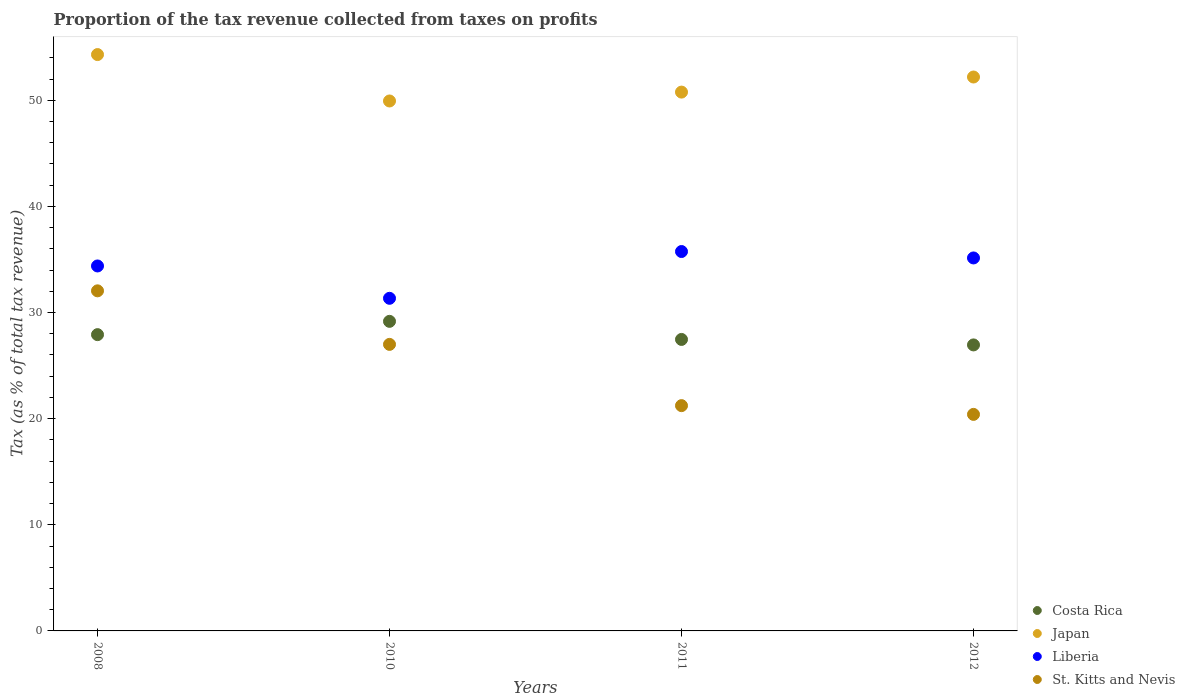What is the proportion of the tax revenue collected in St. Kitts and Nevis in 2012?
Offer a very short reply. 20.4. Across all years, what is the maximum proportion of the tax revenue collected in Japan?
Provide a short and direct response. 54.3. Across all years, what is the minimum proportion of the tax revenue collected in St. Kitts and Nevis?
Your answer should be compact. 20.4. In which year was the proportion of the tax revenue collected in Japan minimum?
Give a very brief answer. 2010. What is the total proportion of the tax revenue collected in Japan in the graph?
Offer a terse response. 207.19. What is the difference between the proportion of the tax revenue collected in Liberia in 2008 and that in 2012?
Keep it short and to the point. -0.76. What is the difference between the proportion of the tax revenue collected in St. Kitts and Nevis in 2011 and the proportion of the tax revenue collected in Liberia in 2008?
Offer a terse response. -13.16. What is the average proportion of the tax revenue collected in St. Kitts and Nevis per year?
Provide a succinct answer. 25.17. In the year 2010, what is the difference between the proportion of the tax revenue collected in Liberia and proportion of the tax revenue collected in Costa Rica?
Your answer should be very brief. 2.17. In how many years, is the proportion of the tax revenue collected in Liberia greater than 14 %?
Your response must be concise. 4. What is the ratio of the proportion of the tax revenue collected in Japan in 2008 to that in 2010?
Your answer should be very brief. 1.09. Is the proportion of the tax revenue collected in Costa Rica in 2008 less than that in 2012?
Ensure brevity in your answer.  No. What is the difference between the highest and the second highest proportion of the tax revenue collected in Liberia?
Provide a short and direct response. 0.6. What is the difference between the highest and the lowest proportion of the tax revenue collected in St. Kitts and Nevis?
Provide a short and direct response. 11.64. In how many years, is the proportion of the tax revenue collected in St. Kitts and Nevis greater than the average proportion of the tax revenue collected in St. Kitts and Nevis taken over all years?
Provide a short and direct response. 2. Is the sum of the proportion of the tax revenue collected in St. Kitts and Nevis in 2011 and 2012 greater than the maximum proportion of the tax revenue collected in Liberia across all years?
Keep it short and to the point. Yes. Is the proportion of the tax revenue collected in Japan strictly greater than the proportion of the tax revenue collected in St. Kitts and Nevis over the years?
Make the answer very short. Yes. Is the proportion of the tax revenue collected in Liberia strictly less than the proportion of the tax revenue collected in St. Kitts and Nevis over the years?
Ensure brevity in your answer.  No. How many dotlines are there?
Offer a terse response. 4. Are the values on the major ticks of Y-axis written in scientific E-notation?
Ensure brevity in your answer.  No. Does the graph contain any zero values?
Your answer should be very brief. No. Where does the legend appear in the graph?
Your response must be concise. Bottom right. What is the title of the graph?
Your answer should be very brief. Proportion of the tax revenue collected from taxes on profits. Does "Sudan" appear as one of the legend labels in the graph?
Make the answer very short. No. What is the label or title of the Y-axis?
Offer a terse response. Tax (as % of total tax revenue). What is the Tax (as % of total tax revenue) of Costa Rica in 2008?
Your response must be concise. 27.91. What is the Tax (as % of total tax revenue) of Japan in 2008?
Offer a terse response. 54.3. What is the Tax (as % of total tax revenue) in Liberia in 2008?
Offer a terse response. 34.38. What is the Tax (as % of total tax revenue) in St. Kitts and Nevis in 2008?
Make the answer very short. 32.04. What is the Tax (as % of total tax revenue) in Costa Rica in 2010?
Keep it short and to the point. 29.17. What is the Tax (as % of total tax revenue) in Japan in 2010?
Your response must be concise. 49.93. What is the Tax (as % of total tax revenue) in Liberia in 2010?
Provide a short and direct response. 31.34. What is the Tax (as % of total tax revenue) in St. Kitts and Nevis in 2010?
Provide a succinct answer. 27. What is the Tax (as % of total tax revenue) of Costa Rica in 2011?
Keep it short and to the point. 27.46. What is the Tax (as % of total tax revenue) in Japan in 2011?
Provide a short and direct response. 50.77. What is the Tax (as % of total tax revenue) of Liberia in 2011?
Ensure brevity in your answer.  35.74. What is the Tax (as % of total tax revenue) of St. Kitts and Nevis in 2011?
Ensure brevity in your answer.  21.23. What is the Tax (as % of total tax revenue) of Costa Rica in 2012?
Your answer should be very brief. 26.95. What is the Tax (as % of total tax revenue) of Japan in 2012?
Ensure brevity in your answer.  52.19. What is the Tax (as % of total tax revenue) in Liberia in 2012?
Provide a short and direct response. 35.14. What is the Tax (as % of total tax revenue) of St. Kitts and Nevis in 2012?
Provide a short and direct response. 20.4. Across all years, what is the maximum Tax (as % of total tax revenue) of Costa Rica?
Ensure brevity in your answer.  29.17. Across all years, what is the maximum Tax (as % of total tax revenue) of Japan?
Give a very brief answer. 54.3. Across all years, what is the maximum Tax (as % of total tax revenue) in Liberia?
Make the answer very short. 35.74. Across all years, what is the maximum Tax (as % of total tax revenue) of St. Kitts and Nevis?
Your answer should be compact. 32.04. Across all years, what is the minimum Tax (as % of total tax revenue) in Costa Rica?
Ensure brevity in your answer.  26.95. Across all years, what is the minimum Tax (as % of total tax revenue) of Japan?
Offer a very short reply. 49.93. Across all years, what is the minimum Tax (as % of total tax revenue) in Liberia?
Your response must be concise. 31.34. Across all years, what is the minimum Tax (as % of total tax revenue) of St. Kitts and Nevis?
Give a very brief answer. 20.4. What is the total Tax (as % of total tax revenue) of Costa Rica in the graph?
Provide a short and direct response. 111.49. What is the total Tax (as % of total tax revenue) in Japan in the graph?
Keep it short and to the point. 207.19. What is the total Tax (as % of total tax revenue) of Liberia in the graph?
Provide a short and direct response. 136.61. What is the total Tax (as % of total tax revenue) in St. Kitts and Nevis in the graph?
Provide a short and direct response. 100.67. What is the difference between the Tax (as % of total tax revenue) in Costa Rica in 2008 and that in 2010?
Your answer should be compact. -1.25. What is the difference between the Tax (as % of total tax revenue) of Japan in 2008 and that in 2010?
Ensure brevity in your answer.  4.37. What is the difference between the Tax (as % of total tax revenue) of Liberia in 2008 and that in 2010?
Provide a short and direct response. 3.05. What is the difference between the Tax (as % of total tax revenue) of St. Kitts and Nevis in 2008 and that in 2010?
Offer a terse response. 5.04. What is the difference between the Tax (as % of total tax revenue) of Costa Rica in 2008 and that in 2011?
Your answer should be compact. 0.45. What is the difference between the Tax (as % of total tax revenue) in Japan in 2008 and that in 2011?
Your answer should be very brief. 3.54. What is the difference between the Tax (as % of total tax revenue) of Liberia in 2008 and that in 2011?
Your answer should be very brief. -1.36. What is the difference between the Tax (as % of total tax revenue) of St. Kitts and Nevis in 2008 and that in 2011?
Offer a terse response. 10.82. What is the difference between the Tax (as % of total tax revenue) of Costa Rica in 2008 and that in 2012?
Provide a succinct answer. 0.97. What is the difference between the Tax (as % of total tax revenue) of Japan in 2008 and that in 2012?
Provide a succinct answer. 2.12. What is the difference between the Tax (as % of total tax revenue) in Liberia in 2008 and that in 2012?
Offer a terse response. -0.76. What is the difference between the Tax (as % of total tax revenue) of St. Kitts and Nevis in 2008 and that in 2012?
Ensure brevity in your answer.  11.64. What is the difference between the Tax (as % of total tax revenue) in Costa Rica in 2010 and that in 2011?
Give a very brief answer. 1.7. What is the difference between the Tax (as % of total tax revenue) of Japan in 2010 and that in 2011?
Your response must be concise. -0.84. What is the difference between the Tax (as % of total tax revenue) in Liberia in 2010 and that in 2011?
Provide a succinct answer. -4.41. What is the difference between the Tax (as % of total tax revenue) of St. Kitts and Nevis in 2010 and that in 2011?
Provide a short and direct response. 5.77. What is the difference between the Tax (as % of total tax revenue) in Costa Rica in 2010 and that in 2012?
Ensure brevity in your answer.  2.22. What is the difference between the Tax (as % of total tax revenue) of Japan in 2010 and that in 2012?
Give a very brief answer. -2.26. What is the difference between the Tax (as % of total tax revenue) of Liberia in 2010 and that in 2012?
Offer a very short reply. -3.8. What is the difference between the Tax (as % of total tax revenue) in St. Kitts and Nevis in 2010 and that in 2012?
Give a very brief answer. 6.6. What is the difference between the Tax (as % of total tax revenue) in Costa Rica in 2011 and that in 2012?
Offer a very short reply. 0.52. What is the difference between the Tax (as % of total tax revenue) in Japan in 2011 and that in 2012?
Provide a succinct answer. -1.42. What is the difference between the Tax (as % of total tax revenue) of Liberia in 2011 and that in 2012?
Your response must be concise. 0.6. What is the difference between the Tax (as % of total tax revenue) in St. Kitts and Nevis in 2011 and that in 2012?
Offer a very short reply. 0.82. What is the difference between the Tax (as % of total tax revenue) in Costa Rica in 2008 and the Tax (as % of total tax revenue) in Japan in 2010?
Provide a short and direct response. -22.02. What is the difference between the Tax (as % of total tax revenue) in Costa Rica in 2008 and the Tax (as % of total tax revenue) in Liberia in 2010?
Provide a succinct answer. -3.42. What is the difference between the Tax (as % of total tax revenue) of Costa Rica in 2008 and the Tax (as % of total tax revenue) of St. Kitts and Nevis in 2010?
Give a very brief answer. 0.92. What is the difference between the Tax (as % of total tax revenue) in Japan in 2008 and the Tax (as % of total tax revenue) in Liberia in 2010?
Make the answer very short. 22.96. What is the difference between the Tax (as % of total tax revenue) in Japan in 2008 and the Tax (as % of total tax revenue) in St. Kitts and Nevis in 2010?
Your answer should be very brief. 27.31. What is the difference between the Tax (as % of total tax revenue) in Liberia in 2008 and the Tax (as % of total tax revenue) in St. Kitts and Nevis in 2010?
Ensure brevity in your answer.  7.39. What is the difference between the Tax (as % of total tax revenue) of Costa Rica in 2008 and the Tax (as % of total tax revenue) of Japan in 2011?
Your response must be concise. -22.85. What is the difference between the Tax (as % of total tax revenue) in Costa Rica in 2008 and the Tax (as % of total tax revenue) in Liberia in 2011?
Make the answer very short. -7.83. What is the difference between the Tax (as % of total tax revenue) in Costa Rica in 2008 and the Tax (as % of total tax revenue) in St. Kitts and Nevis in 2011?
Offer a very short reply. 6.69. What is the difference between the Tax (as % of total tax revenue) of Japan in 2008 and the Tax (as % of total tax revenue) of Liberia in 2011?
Offer a terse response. 18.56. What is the difference between the Tax (as % of total tax revenue) in Japan in 2008 and the Tax (as % of total tax revenue) in St. Kitts and Nevis in 2011?
Provide a succinct answer. 33.08. What is the difference between the Tax (as % of total tax revenue) of Liberia in 2008 and the Tax (as % of total tax revenue) of St. Kitts and Nevis in 2011?
Your answer should be very brief. 13.16. What is the difference between the Tax (as % of total tax revenue) of Costa Rica in 2008 and the Tax (as % of total tax revenue) of Japan in 2012?
Give a very brief answer. -24.27. What is the difference between the Tax (as % of total tax revenue) in Costa Rica in 2008 and the Tax (as % of total tax revenue) in Liberia in 2012?
Provide a short and direct response. -7.23. What is the difference between the Tax (as % of total tax revenue) of Costa Rica in 2008 and the Tax (as % of total tax revenue) of St. Kitts and Nevis in 2012?
Your response must be concise. 7.51. What is the difference between the Tax (as % of total tax revenue) in Japan in 2008 and the Tax (as % of total tax revenue) in Liberia in 2012?
Ensure brevity in your answer.  19.16. What is the difference between the Tax (as % of total tax revenue) in Japan in 2008 and the Tax (as % of total tax revenue) in St. Kitts and Nevis in 2012?
Provide a succinct answer. 33.9. What is the difference between the Tax (as % of total tax revenue) of Liberia in 2008 and the Tax (as % of total tax revenue) of St. Kitts and Nevis in 2012?
Give a very brief answer. 13.98. What is the difference between the Tax (as % of total tax revenue) in Costa Rica in 2010 and the Tax (as % of total tax revenue) in Japan in 2011?
Offer a terse response. -21.6. What is the difference between the Tax (as % of total tax revenue) in Costa Rica in 2010 and the Tax (as % of total tax revenue) in Liberia in 2011?
Give a very brief answer. -6.58. What is the difference between the Tax (as % of total tax revenue) in Costa Rica in 2010 and the Tax (as % of total tax revenue) in St. Kitts and Nevis in 2011?
Keep it short and to the point. 7.94. What is the difference between the Tax (as % of total tax revenue) of Japan in 2010 and the Tax (as % of total tax revenue) of Liberia in 2011?
Ensure brevity in your answer.  14.18. What is the difference between the Tax (as % of total tax revenue) of Japan in 2010 and the Tax (as % of total tax revenue) of St. Kitts and Nevis in 2011?
Offer a very short reply. 28.7. What is the difference between the Tax (as % of total tax revenue) of Liberia in 2010 and the Tax (as % of total tax revenue) of St. Kitts and Nevis in 2011?
Ensure brevity in your answer.  10.11. What is the difference between the Tax (as % of total tax revenue) in Costa Rica in 2010 and the Tax (as % of total tax revenue) in Japan in 2012?
Provide a short and direct response. -23.02. What is the difference between the Tax (as % of total tax revenue) of Costa Rica in 2010 and the Tax (as % of total tax revenue) of Liberia in 2012?
Your answer should be compact. -5.97. What is the difference between the Tax (as % of total tax revenue) of Costa Rica in 2010 and the Tax (as % of total tax revenue) of St. Kitts and Nevis in 2012?
Keep it short and to the point. 8.77. What is the difference between the Tax (as % of total tax revenue) of Japan in 2010 and the Tax (as % of total tax revenue) of Liberia in 2012?
Provide a succinct answer. 14.79. What is the difference between the Tax (as % of total tax revenue) of Japan in 2010 and the Tax (as % of total tax revenue) of St. Kitts and Nevis in 2012?
Make the answer very short. 29.53. What is the difference between the Tax (as % of total tax revenue) of Liberia in 2010 and the Tax (as % of total tax revenue) of St. Kitts and Nevis in 2012?
Ensure brevity in your answer.  10.94. What is the difference between the Tax (as % of total tax revenue) in Costa Rica in 2011 and the Tax (as % of total tax revenue) in Japan in 2012?
Your answer should be compact. -24.72. What is the difference between the Tax (as % of total tax revenue) in Costa Rica in 2011 and the Tax (as % of total tax revenue) in Liberia in 2012?
Ensure brevity in your answer.  -7.68. What is the difference between the Tax (as % of total tax revenue) in Costa Rica in 2011 and the Tax (as % of total tax revenue) in St. Kitts and Nevis in 2012?
Provide a short and direct response. 7.06. What is the difference between the Tax (as % of total tax revenue) of Japan in 2011 and the Tax (as % of total tax revenue) of Liberia in 2012?
Give a very brief answer. 15.63. What is the difference between the Tax (as % of total tax revenue) of Japan in 2011 and the Tax (as % of total tax revenue) of St. Kitts and Nevis in 2012?
Make the answer very short. 30.37. What is the difference between the Tax (as % of total tax revenue) in Liberia in 2011 and the Tax (as % of total tax revenue) in St. Kitts and Nevis in 2012?
Ensure brevity in your answer.  15.34. What is the average Tax (as % of total tax revenue) of Costa Rica per year?
Provide a short and direct response. 27.87. What is the average Tax (as % of total tax revenue) of Japan per year?
Your response must be concise. 51.8. What is the average Tax (as % of total tax revenue) in Liberia per year?
Your answer should be very brief. 34.15. What is the average Tax (as % of total tax revenue) of St. Kitts and Nevis per year?
Your answer should be very brief. 25.17. In the year 2008, what is the difference between the Tax (as % of total tax revenue) in Costa Rica and Tax (as % of total tax revenue) in Japan?
Provide a short and direct response. -26.39. In the year 2008, what is the difference between the Tax (as % of total tax revenue) in Costa Rica and Tax (as % of total tax revenue) in Liberia?
Make the answer very short. -6.47. In the year 2008, what is the difference between the Tax (as % of total tax revenue) in Costa Rica and Tax (as % of total tax revenue) in St. Kitts and Nevis?
Your response must be concise. -4.13. In the year 2008, what is the difference between the Tax (as % of total tax revenue) of Japan and Tax (as % of total tax revenue) of Liberia?
Give a very brief answer. 19.92. In the year 2008, what is the difference between the Tax (as % of total tax revenue) in Japan and Tax (as % of total tax revenue) in St. Kitts and Nevis?
Your answer should be very brief. 22.26. In the year 2008, what is the difference between the Tax (as % of total tax revenue) in Liberia and Tax (as % of total tax revenue) in St. Kitts and Nevis?
Offer a terse response. 2.34. In the year 2010, what is the difference between the Tax (as % of total tax revenue) in Costa Rica and Tax (as % of total tax revenue) in Japan?
Provide a short and direct response. -20.76. In the year 2010, what is the difference between the Tax (as % of total tax revenue) of Costa Rica and Tax (as % of total tax revenue) of Liberia?
Ensure brevity in your answer.  -2.17. In the year 2010, what is the difference between the Tax (as % of total tax revenue) of Costa Rica and Tax (as % of total tax revenue) of St. Kitts and Nevis?
Offer a terse response. 2.17. In the year 2010, what is the difference between the Tax (as % of total tax revenue) in Japan and Tax (as % of total tax revenue) in Liberia?
Keep it short and to the point. 18.59. In the year 2010, what is the difference between the Tax (as % of total tax revenue) in Japan and Tax (as % of total tax revenue) in St. Kitts and Nevis?
Ensure brevity in your answer.  22.93. In the year 2010, what is the difference between the Tax (as % of total tax revenue) of Liberia and Tax (as % of total tax revenue) of St. Kitts and Nevis?
Offer a very short reply. 4.34. In the year 2011, what is the difference between the Tax (as % of total tax revenue) in Costa Rica and Tax (as % of total tax revenue) in Japan?
Provide a succinct answer. -23.3. In the year 2011, what is the difference between the Tax (as % of total tax revenue) of Costa Rica and Tax (as % of total tax revenue) of Liberia?
Ensure brevity in your answer.  -8.28. In the year 2011, what is the difference between the Tax (as % of total tax revenue) of Costa Rica and Tax (as % of total tax revenue) of St. Kitts and Nevis?
Keep it short and to the point. 6.24. In the year 2011, what is the difference between the Tax (as % of total tax revenue) in Japan and Tax (as % of total tax revenue) in Liberia?
Offer a very short reply. 15.02. In the year 2011, what is the difference between the Tax (as % of total tax revenue) of Japan and Tax (as % of total tax revenue) of St. Kitts and Nevis?
Offer a terse response. 29.54. In the year 2011, what is the difference between the Tax (as % of total tax revenue) in Liberia and Tax (as % of total tax revenue) in St. Kitts and Nevis?
Offer a very short reply. 14.52. In the year 2012, what is the difference between the Tax (as % of total tax revenue) in Costa Rica and Tax (as % of total tax revenue) in Japan?
Give a very brief answer. -25.24. In the year 2012, what is the difference between the Tax (as % of total tax revenue) of Costa Rica and Tax (as % of total tax revenue) of Liberia?
Your answer should be compact. -8.19. In the year 2012, what is the difference between the Tax (as % of total tax revenue) in Costa Rica and Tax (as % of total tax revenue) in St. Kitts and Nevis?
Offer a very short reply. 6.55. In the year 2012, what is the difference between the Tax (as % of total tax revenue) of Japan and Tax (as % of total tax revenue) of Liberia?
Provide a succinct answer. 17.05. In the year 2012, what is the difference between the Tax (as % of total tax revenue) of Japan and Tax (as % of total tax revenue) of St. Kitts and Nevis?
Provide a succinct answer. 31.79. In the year 2012, what is the difference between the Tax (as % of total tax revenue) in Liberia and Tax (as % of total tax revenue) in St. Kitts and Nevis?
Keep it short and to the point. 14.74. What is the ratio of the Tax (as % of total tax revenue) in Costa Rica in 2008 to that in 2010?
Your response must be concise. 0.96. What is the ratio of the Tax (as % of total tax revenue) of Japan in 2008 to that in 2010?
Your answer should be very brief. 1.09. What is the ratio of the Tax (as % of total tax revenue) of Liberia in 2008 to that in 2010?
Ensure brevity in your answer.  1.1. What is the ratio of the Tax (as % of total tax revenue) of St. Kitts and Nevis in 2008 to that in 2010?
Provide a short and direct response. 1.19. What is the ratio of the Tax (as % of total tax revenue) in Costa Rica in 2008 to that in 2011?
Offer a terse response. 1.02. What is the ratio of the Tax (as % of total tax revenue) in Japan in 2008 to that in 2011?
Your answer should be compact. 1.07. What is the ratio of the Tax (as % of total tax revenue) in St. Kitts and Nevis in 2008 to that in 2011?
Make the answer very short. 1.51. What is the ratio of the Tax (as % of total tax revenue) of Costa Rica in 2008 to that in 2012?
Your answer should be very brief. 1.04. What is the ratio of the Tax (as % of total tax revenue) in Japan in 2008 to that in 2012?
Provide a succinct answer. 1.04. What is the ratio of the Tax (as % of total tax revenue) of Liberia in 2008 to that in 2012?
Your answer should be compact. 0.98. What is the ratio of the Tax (as % of total tax revenue) in St. Kitts and Nevis in 2008 to that in 2012?
Make the answer very short. 1.57. What is the ratio of the Tax (as % of total tax revenue) in Costa Rica in 2010 to that in 2011?
Provide a succinct answer. 1.06. What is the ratio of the Tax (as % of total tax revenue) of Japan in 2010 to that in 2011?
Make the answer very short. 0.98. What is the ratio of the Tax (as % of total tax revenue) of Liberia in 2010 to that in 2011?
Your answer should be compact. 0.88. What is the ratio of the Tax (as % of total tax revenue) in St. Kitts and Nevis in 2010 to that in 2011?
Keep it short and to the point. 1.27. What is the ratio of the Tax (as % of total tax revenue) of Costa Rica in 2010 to that in 2012?
Your answer should be compact. 1.08. What is the ratio of the Tax (as % of total tax revenue) in Japan in 2010 to that in 2012?
Provide a succinct answer. 0.96. What is the ratio of the Tax (as % of total tax revenue) in Liberia in 2010 to that in 2012?
Make the answer very short. 0.89. What is the ratio of the Tax (as % of total tax revenue) in St. Kitts and Nevis in 2010 to that in 2012?
Ensure brevity in your answer.  1.32. What is the ratio of the Tax (as % of total tax revenue) in Costa Rica in 2011 to that in 2012?
Your response must be concise. 1.02. What is the ratio of the Tax (as % of total tax revenue) in Japan in 2011 to that in 2012?
Offer a terse response. 0.97. What is the ratio of the Tax (as % of total tax revenue) of Liberia in 2011 to that in 2012?
Your answer should be very brief. 1.02. What is the ratio of the Tax (as % of total tax revenue) of St. Kitts and Nevis in 2011 to that in 2012?
Provide a short and direct response. 1.04. What is the difference between the highest and the second highest Tax (as % of total tax revenue) of Costa Rica?
Give a very brief answer. 1.25. What is the difference between the highest and the second highest Tax (as % of total tax revenue) of Japan?
Keep it short and to the point. 2.12. What is the difference between the highest and the second highest Tax (as % of total tax revenue) of Liberia?
Provide a succinct answer. 0.6. What is the difference between the highest and the second highest Tax (as % of total tax revenue) in St. Kitts and Nevis?
Make the answer very short. 5.04. What is the difference between the highest and the lowest Tax (as % of total tax revenue) in Costa Rica?
Keep it short and to the point. 2.22. What is the difference between the highest and the lowest Tax (as % of total tax revenue) of Japan?
Offer a very short reply. 4.37. What is the difference between the highest and the lowest Tax (as % of total tax revenue) of Liberia?
Make the answer very short. 4.41. What is the difference between the highest and the lowest Tax (as % of total tax revenue) in St. Kitts and Nevis?
Your answer should be compact. 11.64. 